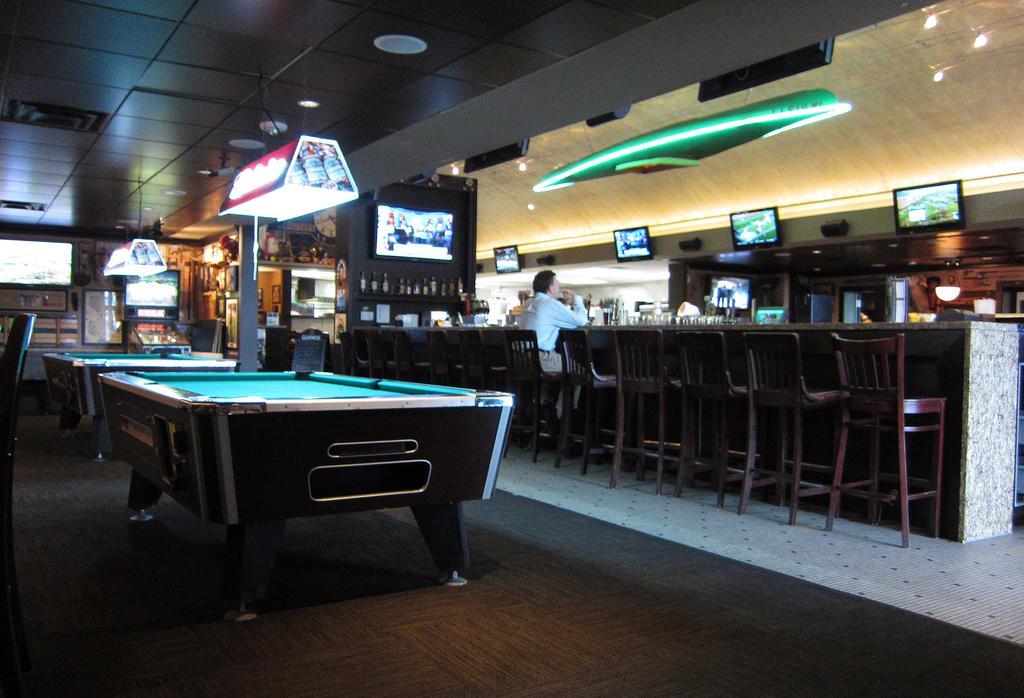How would you summarize this image in a sentence or two? This might be a picture of a bar. In the background there are many televisions. In the center of the picture there are poker tables. In this image there are many chairs. In the center a person is seated. In the background there are bottles in the desk. 